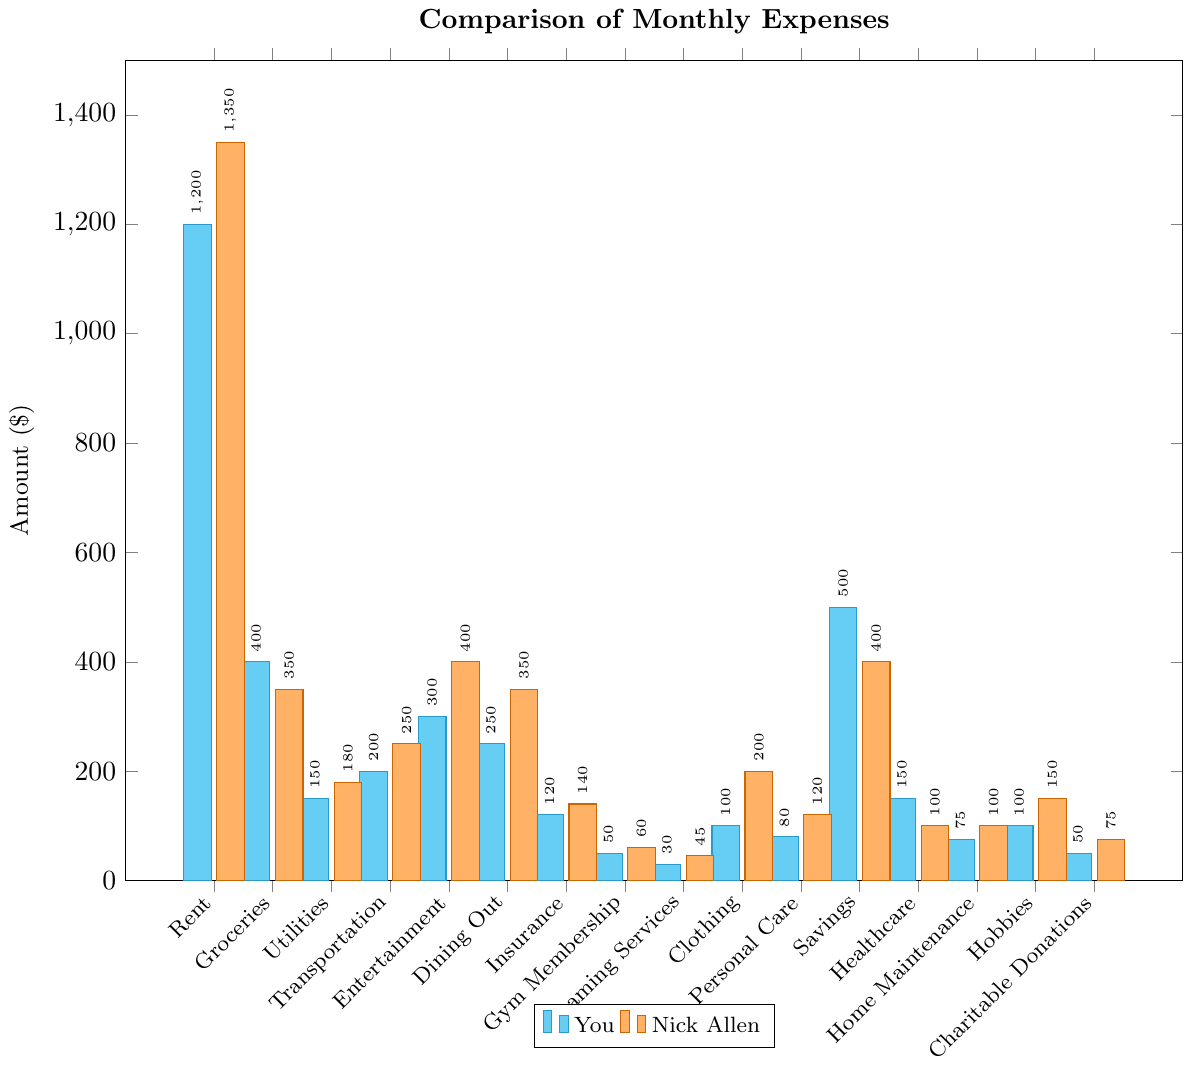What is the most significant difference in expenses between you and Nick Allen? The most significant difference can be identified by comparing the differences between corresponding bars. For "Rent", Nick Allen spends $1350 while you spend $1200. This difference of $150 is the largest among all categories.
Answer: Rent ($150 more for Nick Allen) Which category shows the least difference in expenses between you and Nick Allen? The least difference can be identified by comparing the differences between corresponding bars. For "Streaming Services", Nick Allen spends $45 while you spend $30, resulting in a difference of $15. This is the smallest difference among all categories.
Answer: Streaming Services ($15 more for Nick Allen) How much more does Nick Allen spend on Dining Out compared to you? To find the difference in "Dining Out" expenses, subtract your expense ($250) from Nick Allen's expense ($350). The difference is $350 - $250 = $100.
Answer: $100 What is the total amount spent by you on Rent and Savings? Add the amounts for "Rent" and "Savings". For you, Rent is $1200 and Savings is $500. The total is $1200 + $500 = $1700.
Answer: $1700 Which categories have higher expenses for you than for Nick Allen? Examine the bars to see which are higher for you compared to Nick Allen. You spend more on Groceries ($400 vs. $350), Healthcare ($150 vs. $100), and Savings ($500 vs. $400).
Answer: Groceries, Healthcare, Savings What is the combined total expense for you and Nick Allen on Transportation? Add the Transportation expenses for both you and Nick Allen. You spend $200 and Nick Allen spends $250. The combined total is $200 + $250 = $450.
Answer: $450 Which category shows the greatest expenditure by Nick Allen? Compare the heights of the bars for Nick Allen's expenses. The highest expenditure is on Rent, where Nick Allen spends $1350.
Answer: Rent ($1350) How much do you and Nick Allen spend in total on Entertainment and Dining Out combined? Add the expenses for Entertainment and Dining Out for both individuals. For you, that is $300 (Entertainment) + $250 (Dining Out) = $550. For Nick Allen, it is $400 (Entertainment) + $350 (Dining Out) = $750. The combined total is $550 + $750 = $1300.
Answer: $1300 In which category do you have the exact same expense as Nick Allen? Identify the categories where your expense equals Nick Allen's. In this case, there are no categories where the expenses are exactly the same.
Answer: None What is the average expenditure of Nick Allen across all categories? Add up all categories' expenses for Nick Allen and divide by the number of categories. The total is $5680 (sum of all categories), with 16 categories. The average is $5680 / 16 = $355.
Answer: $355 